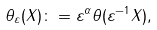<formula> <loc_0><loc_0><loc_500><loc_500>\theta _ { \varepsilon } ( X ) \colon = \varepsilon ^ { \alpha } \theta ( \varepsilon ^ { - 1 } X ) ,</formula> 